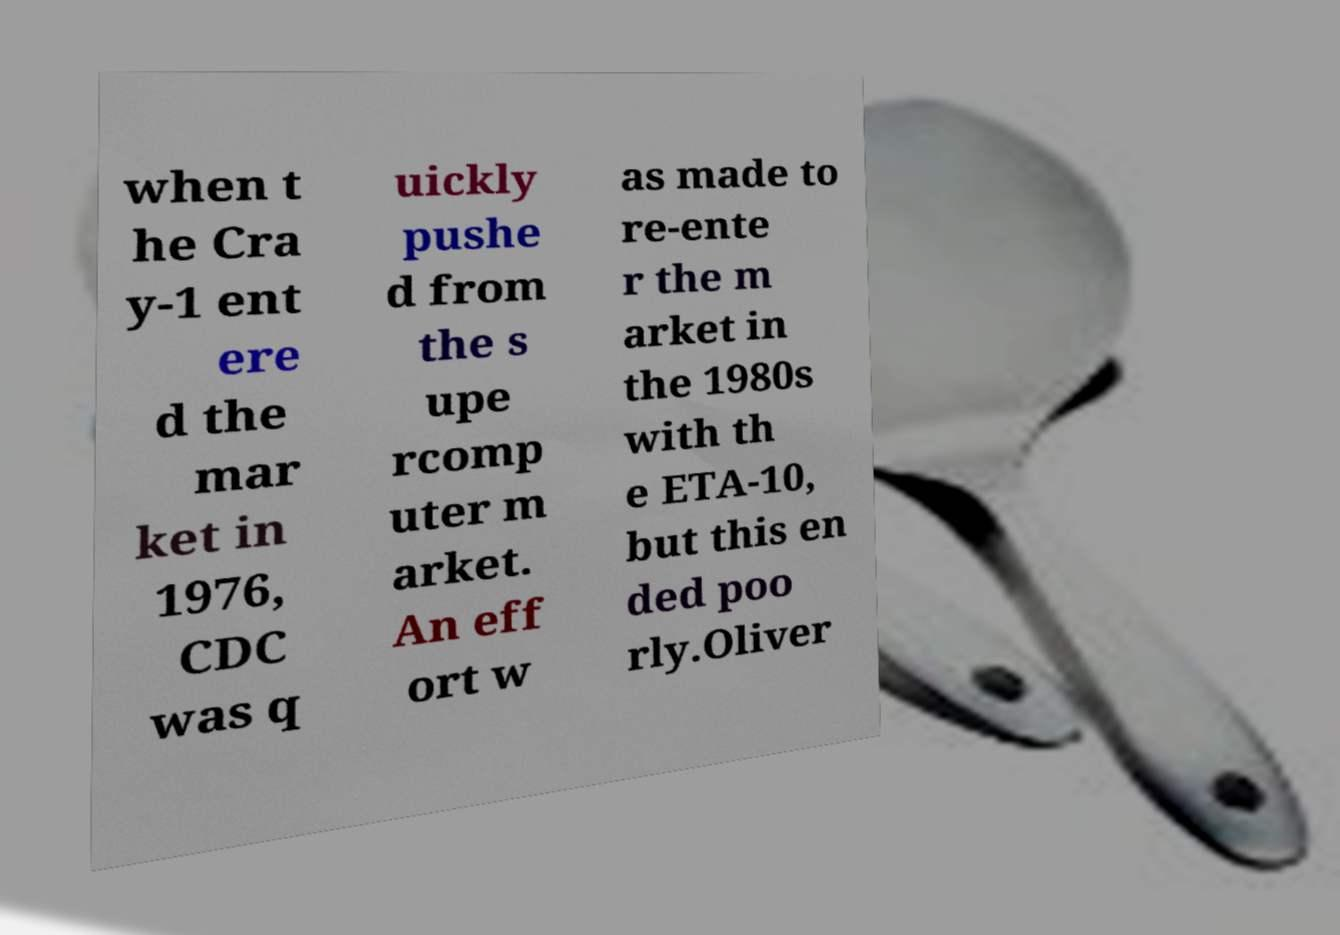Please read and relay the text visible in this image. What does it say? when t he Cra y-1 ent ere d the mar ket in 1976, CDC was q uickly pushe d from the s upe rcomp uter m arket. An eff ort w as made to re-ente r the m arket in the 1980s with th e ETA-10, but this en ded poo rly.Oliver 